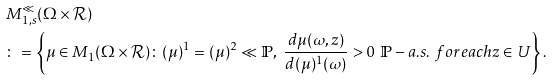<formula> <loc_0><loc_0><loc_500><loc_500>& M _ { 1 , s } ^ { \ll } ( \Omega \times \mathcal { R } ) \\ & \colon = \left \{ \mu \in M _ { 1 } ( \Omega \times \mathcal { R } ) \colon ( \mu ) ^ { 1 } = ( \mu ) ^ { 2 } \ll \mathbb { P } , \ \frac { d \mu ( \omega , z ) } { d ( \mu ) ^ { 1 } ( \omega ) } > 0 \ \mathbb { P } - a . s . \ f o r e a c h z \in U \right \} .</formula> 